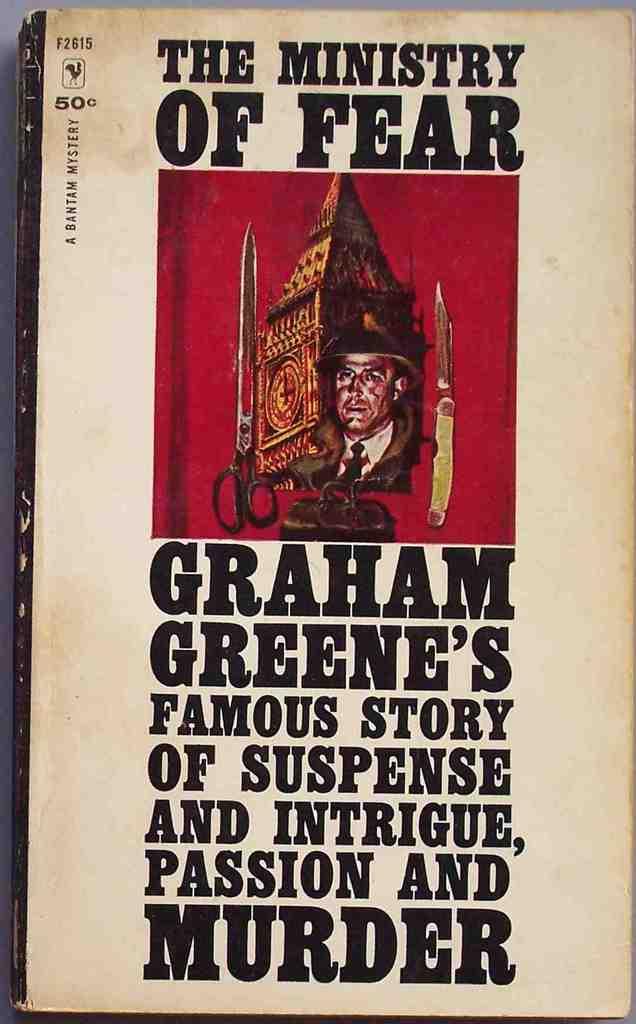What is the price of this book?
Provide a succinct answer. 50 cents. Whose famous story is this?
Provide a short and direct response. Graham greene's. 